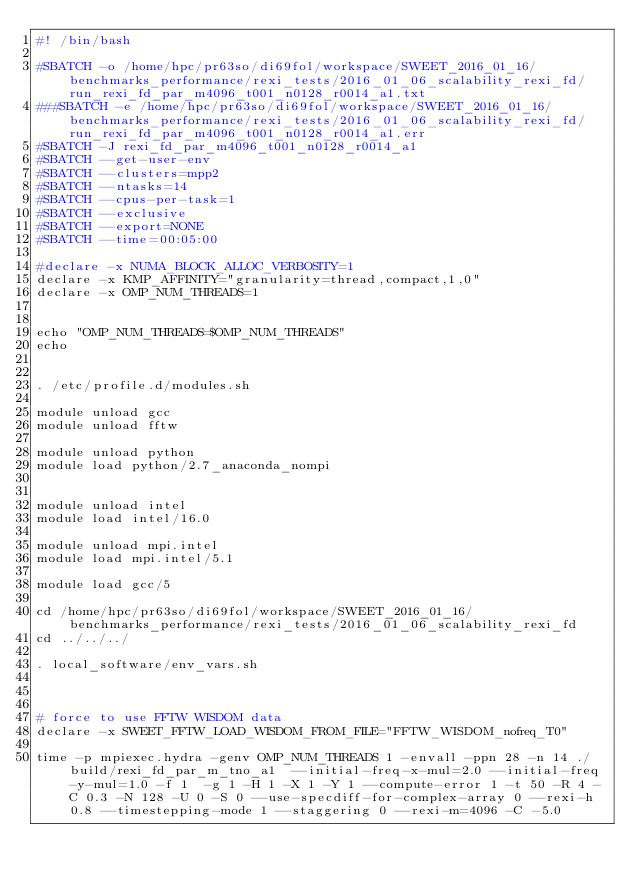Convert code to text. <code><loc_0><loc_0><loc_500><loc_500><_Bash_>#! /bin/bash

#SBATCH -o /home/hpc/pr63so/di69fol/workspace/SWEET_2016_01_16/benchmarks_performance/rexi_tests/2016_01_06_scalability_rexi_fd/run_rexi_fd_par_m4096_t001_n0128_r0014_a1.txt
###SBATCH -e /home/hpc/pr63so/di69fol/workspace/SWEET_2016_01_16/benchmarks_performance/rexi_tests/2016_01_06_scalability_rexi_fd/run_rexi_fd_par_m4096_t001_n0128_r0014_a1.err
#SBATCH -J rexi_fd_par_m4096_t001_n0128_r0014_a1
#SBATCH --get-user-env
#SBATCH --clusters=mpp2
#SBATCH --ntasks=14
#SBATCH --cpus-per-task=1
#SBATCH --exclusive
#SBATCH --export=NONE
#SBATCH --time=00:05:00

#declare -x NUMA_BLOCK_ALLOC_VERBOSITY=1
declare -x KMP_AFFINITY="granularity=thread,compact,1,0"
declare -x OMP_NUM_THREADS=1


echo "OMP_NUM_THREADS=$OMP_NUM_THREADS"
echo


. /etc/profile.d/modules.sh

module unload gcc
module unload fftw

module unload python
module load python/2.7_anaconda_nompi


module unload intel
module load intel/16.0

module unload mpi.intel
module load mpi.intel/5.1

module load gcc/5

cd /home/hpc/pr63so/di69fol/workspace/SWEET_2016_01_16/benchmarks_performance/rexi_tests/2016_01_06_scalability_rexi_fd
cd ../../../

. local_software/env_vars.sh



# force to use FFTW WISDOM data
declare -x SWEET_FFTW_LOAD_WISDOM_FROM_FILE="FFTW_WISDOM_nofreq_T0"

time -p mpiexec.hydra -genv OMP_NUM_THREADS 1 -envall -ppn 28 -n 14 ./build/rexi_fd_par_m_tno_a1  --initial-freq-x-mul=2.0 --initial-freq-y-mul=1.0 -f 1  -g 1 -H 1 -X 1 -Y 1 --compute-error 1 -t 50 -R 4 -C 0.3 -N 128 -U 0 -S 0 --use-specdiff-for-complex-array 0 --rexi-h 0.8 --timestepping-mode 1 --staggering 0 --rexi-m=4096 -C -5.0

</code> 